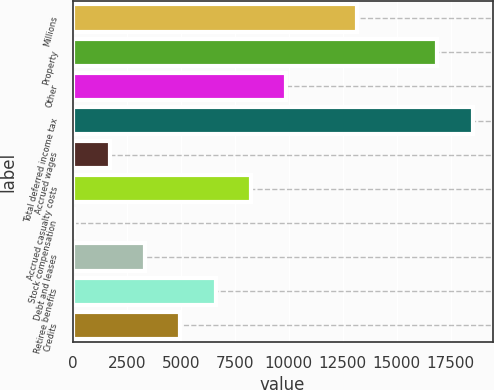Convert chart to OTSL. <chart><loc_0><loc_0><loc_500><loc_500><bar_chart><fcel>Millions<fcel>Property<fcel>Other<fcel>Total deferred income tax<fcel>Accrued wages<fcel>Accrued casualty costs<fcel>Stock compensation<fcel>Debt and leases<fcel>Retiree benefits<fcel>Credits<nl><fcel>13159.2<fcel>16876.9<fcel>9887.4<fcel>18512.8<fcel>1707.9<fcel>8251.5<fcel>72<fcel>3343.8<fcel>6615.6<fcel>4979.7<nl></chart> 